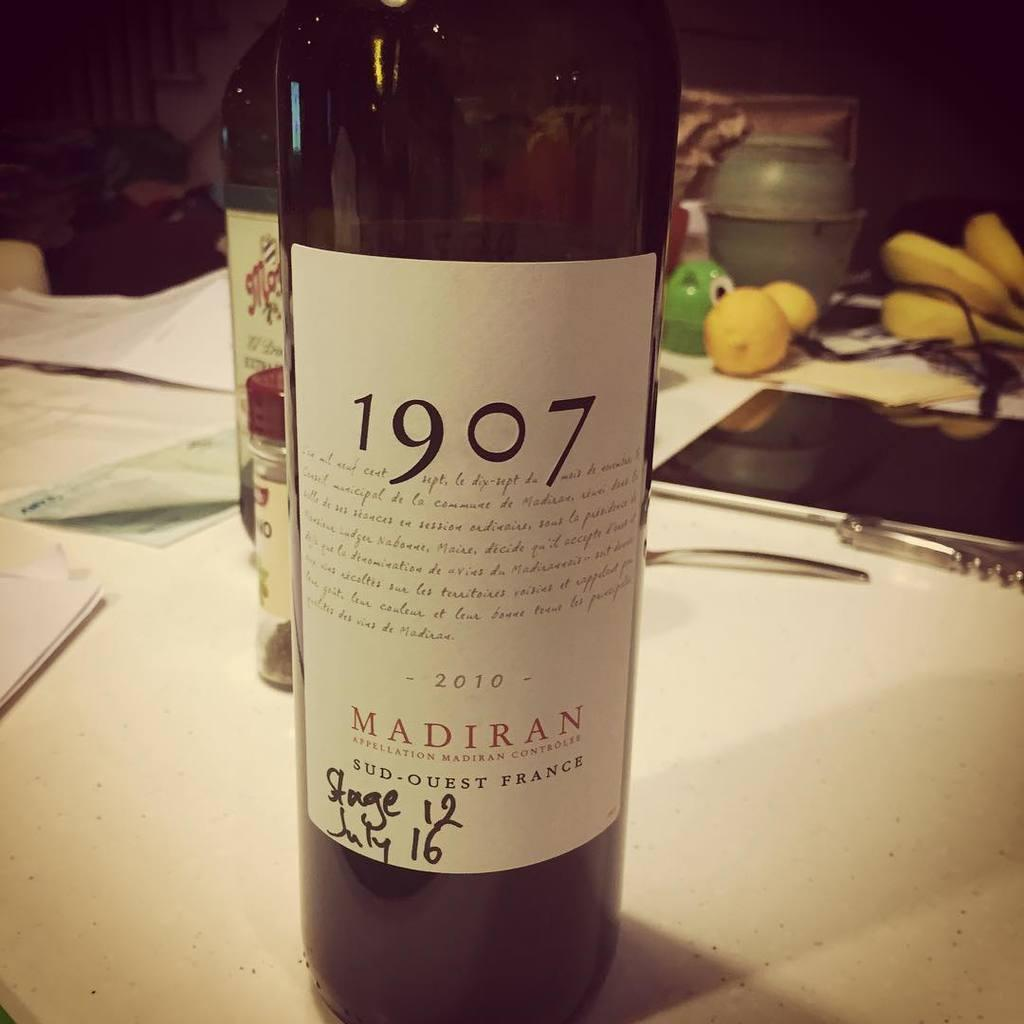<image>
Give a short and clear explanation of the subsequent image. A bottle of wine says "1907" on the label. 